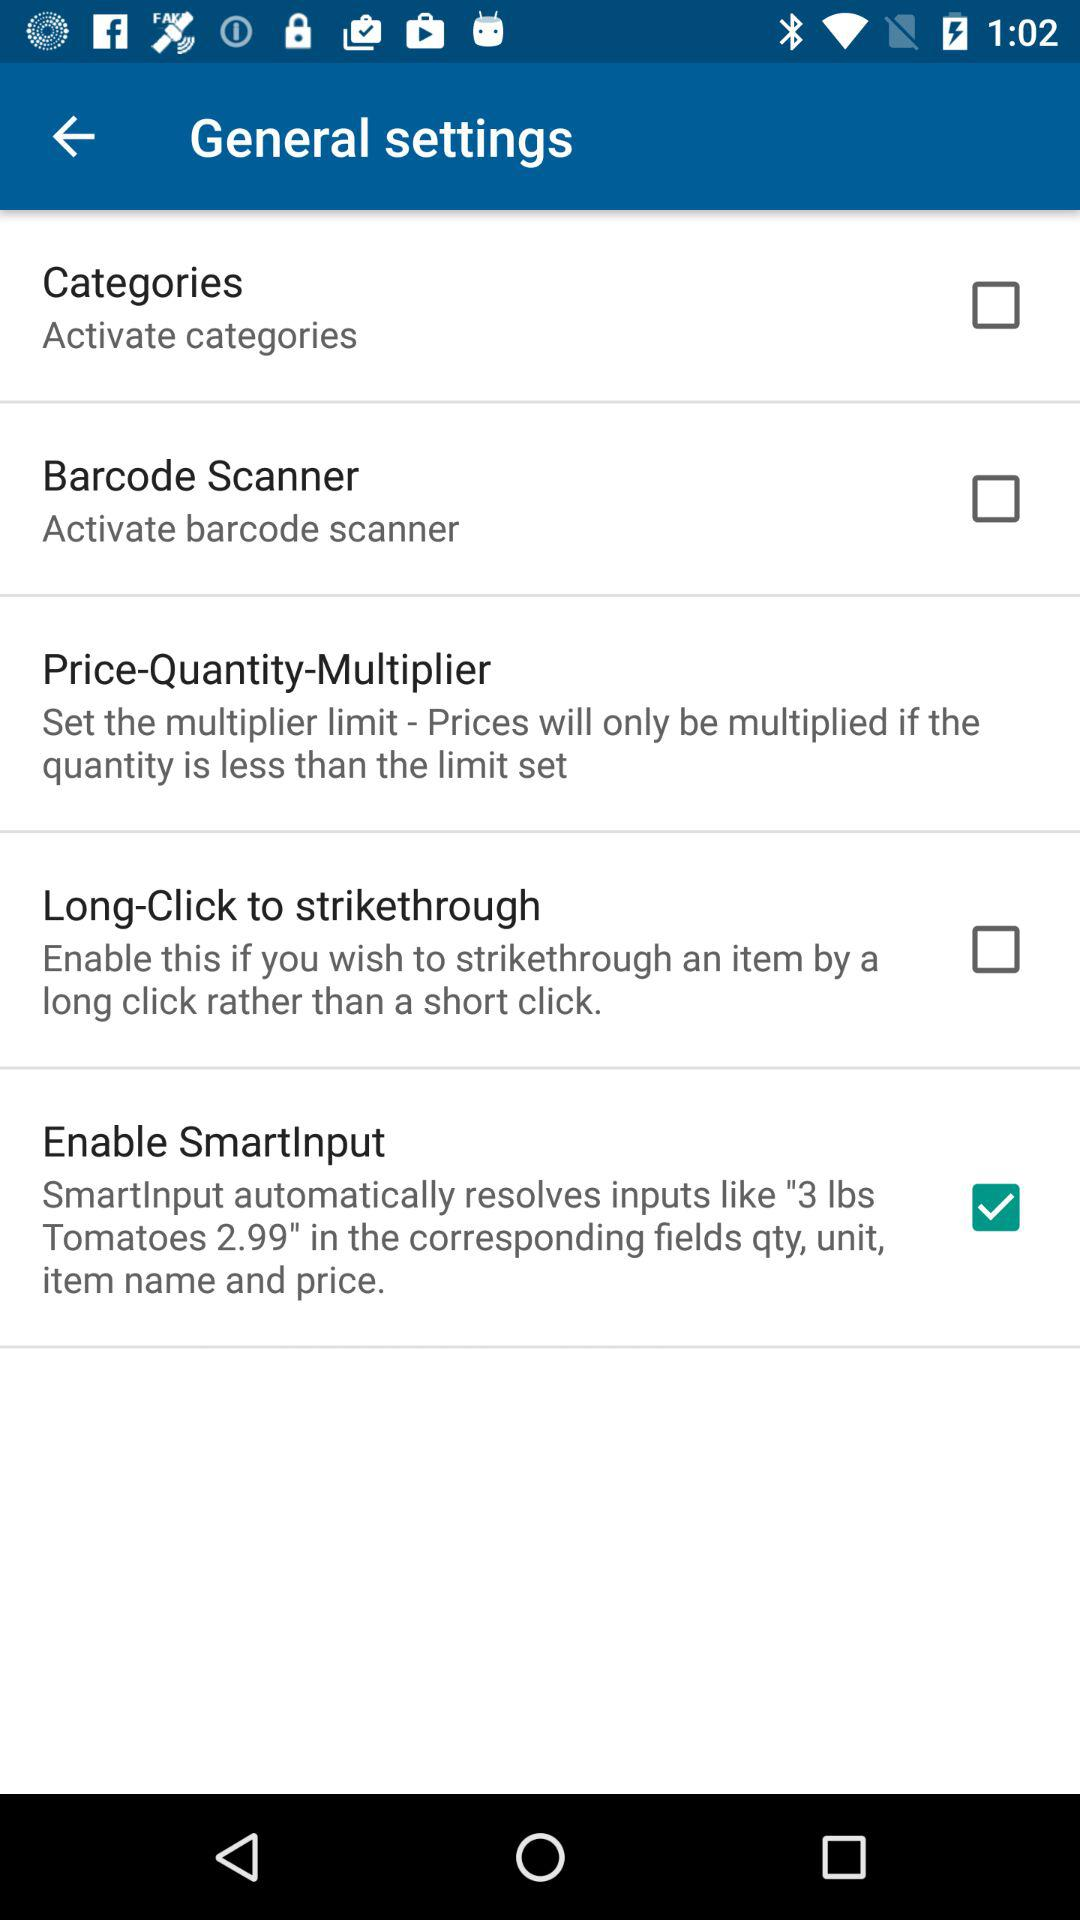How many categories are available?
When the provided information is insufficient, respond with <no answer>. <no answer> 